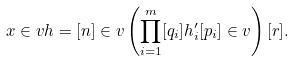<formula> <loc_0><loc_0><loc_500><loc_500>x \in v h = [ n ] \in v \left ( \prod _ { i = 1 } ^ { m } [ q _ { i } ] h _ { i } ^ { \prime } [ p _ { i } ] \in v \right ) [ r ] .</formula> 